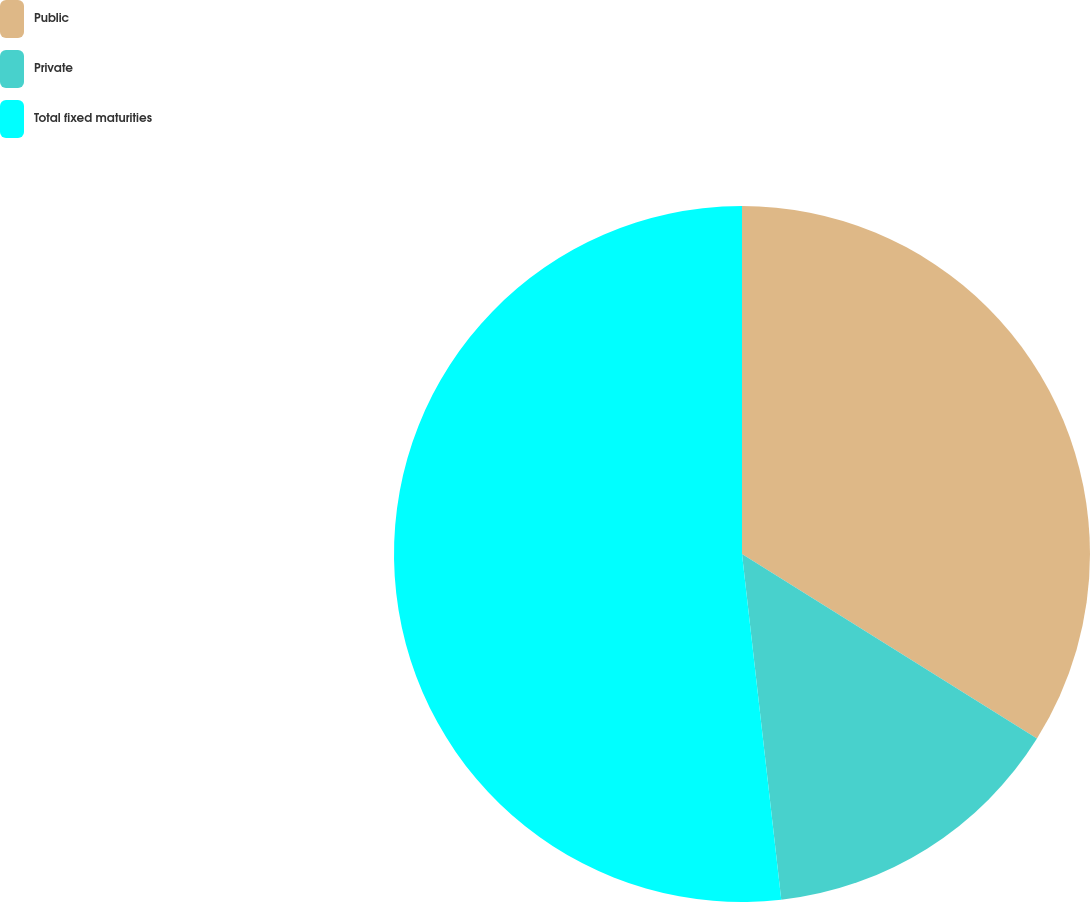Convert chart to OTSL. <chart><loc_0><loc_0><loc_500><loc_500><pie_chart><fcel>Public<fcel>Private<fcel>Total fixed maturities<nl><fcel>33.9%<fcel>14.3%<fcel>51.8%<nl></chart> 